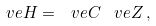<formula> <loc_0><loc_0><loc_500><loc_500>\ v e { H } = \ v e { C } \, \ v e { Z } \, ,</formula> 